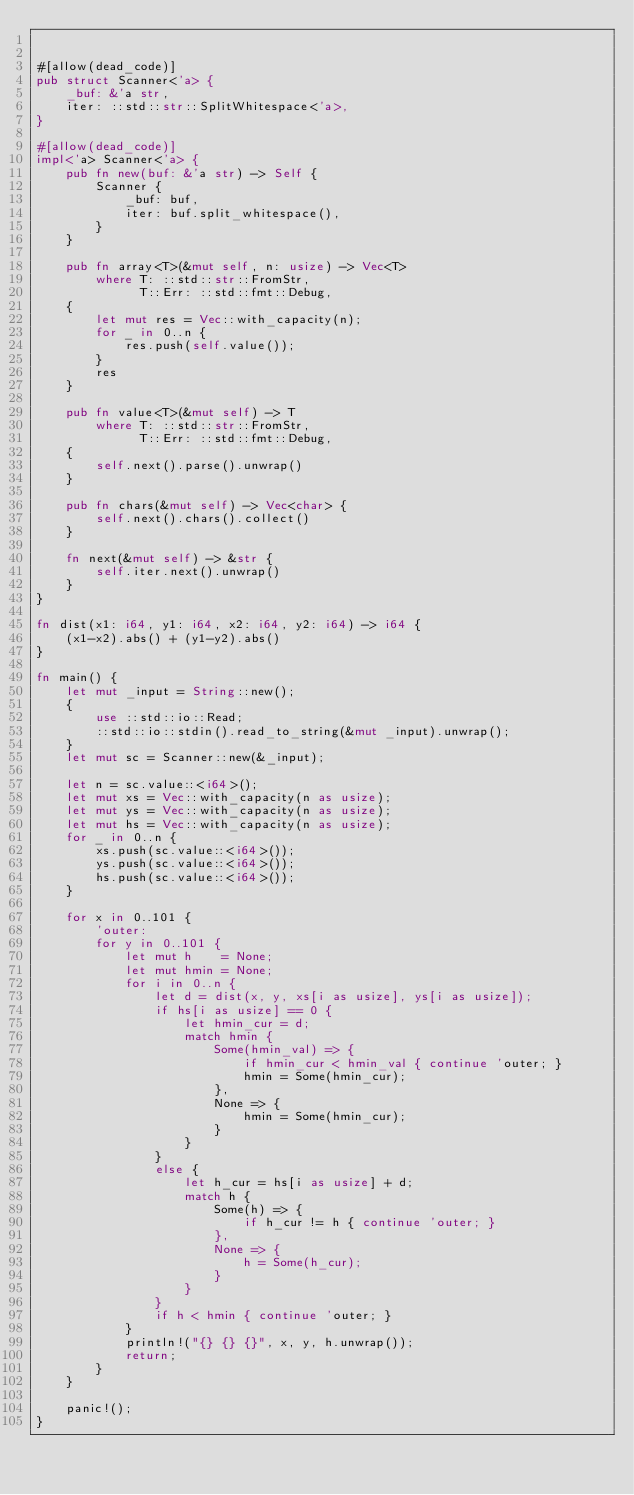<code> <loc_0><loc_0><loc_500><loc_500><_Rust_>

#[allow(dead_code)]
pub struct Scanner<'a> {
    _buf: &'a str,
    iter: ::std::str::SplitWhitespace<'a>,
}

#[allow(dead_code)]
impl<'a> Scanner<'a> {
    pub fn new(buf: &'a str) -> Self {
        Scanner {
            _buf: buf,
            iter: buf.split_whitespace(),
        }
    }

    pub fn array<T>(&mut self, n: usize) -> Vec<T>
        where T: ::std::str::FromStr,
              T::Err: ::std::fmt::Debug,
    {
        let mut res = Vec::with_capacity(n);
        for _ in 0..n {
            res.push(self.value());
        }
        res
    }

    pub fn value<T>(&mut self) -> T
        where T: ::std::str::FromStr,
              T::Err: ::std::fmt::Debug,
    {
        self.next().parse().unwrap()
    }

    pub fn chars(&mut self) -> Vec<char> {
        self.next().chars().collect()
    }

    fn next(&mut self) -> &str {
        self.iter.next().unwrap()
    }
}

fn dist(x1: i64, y1: i64, x2: i64, y2: i64) -> i64 {
    (x1-x2).abs() + (y1-y2).abs()
}

fn main() {
    let mut _input = String::new();
    {
        use ::std::io::Read;
        ::std::io::stdin().read_to_string(&mut _input).unwrap();
    }
    let mut sc = Scanner::new(&_input);

    let n = sc.value::<i64>();
    let mut xs = Vec::with_capacity(n as usize);
    let mut ys = Vec::with_capacity(n as usize);
    let mut hs = Vec::with_capacity(n as usize);
    for _ in 0..n {
        xs.push(sc.value::<i64>());
        ys.push(sc.value::<i64>());
        hs.push(sc.value::<i64>());
    }

    for x in 0..101 {
        'outer:
        for y in 0..101 {
            let mut h    = None;
            let mut hmin = None;
            for i in 0..n {
                let d = dist(x, y, xs[i as usize], ys[i as usize]);
                if hs[i as usize] == 0 {
                    let hmin_cur = d;
                    match hmin {
                        Some(hmin_val) => {
                            if hmin_cur < hmin_val { continue 'outer; }
                            hmin = Some(hmin_cur);
                        },
                        None => {
                            hmin = Some(hmin_cur);
                        }
                    }
                }
                else {
                    let h_cur = hs[i as usize] + d;
                    match h {
                        Some(h) => {
                            if h_cur != h { continue 'outer; }
                        },
                        None => {
                            h = Some(h_cur);
                        }
                    }
                }
                if h < hmin { continue 'outer; }
            }
            println!("{} {} {}", x, y, h.unwrap());
            return;
        }
    }

    panic!();
}
</code> 